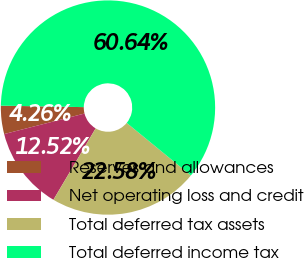Convert chart. <chart><loc_0><loc_0><loc_500><loc_500><pie_chart><fcel>Reserves and allowances<fcel>Net operating loss and credit<fcel>Total deferred tax assets<fcel>Total deferred income tax<nl><fcel>4.26%<fcel>12.52%<fcel>22.58%<fcel>60.65%<nl></chart> 